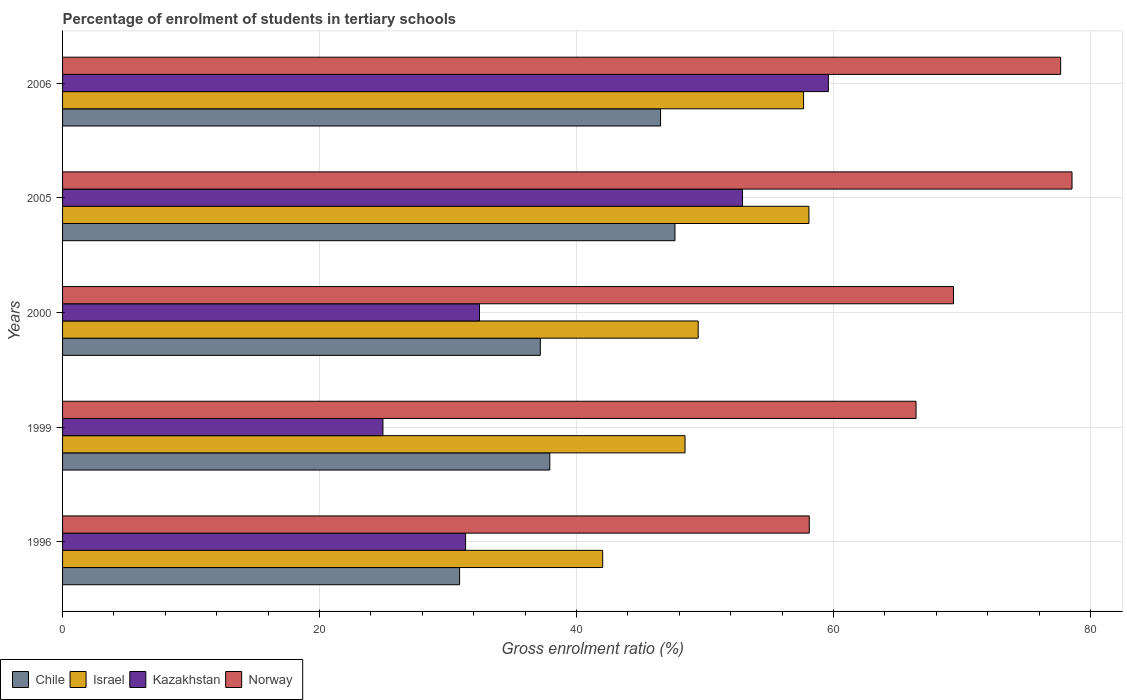How many different coloured bars are there?
Ensure brevity in your answer.  4. Are the number of bars on each tick of the Y-axis equal?
Ensure brevity in your answer.  Yes. How many bars are there on the 2nd tick from the top?
Provide a succinct answer. 4. What is the percentage of students enrolled in tertiary schools in Kazakhstan in 1999?
Your answer should be compact. 24.93. Across all years, what is the maximum percentage of students enrolled in tertiary schools in Israel?
Ensure brevity in your answer.  58.09. Across all years, what is the minimum percentage of students enrolled in tertiary schools in Chile?
Your answer should be very brief. 30.9. What is the total percentage of students enrolled in tertiary schools in Israel in the graph?
Your answer should be compact. 255.72. What is the difference between the percentage of students enrolled in tertiary schools in Kazakhstan in 1999 and that in 2006?
Ensure brevity in your answer.  -34.67. What is the difference between the percentage of students enrolled in tertiary schools in Norway in 1996 and the percentage of students enrolled in tertiary schools in Chile in 2000?
Give a very brief answer. 20.93. What is the average percentage of students enrolled in tertiary schools in Israel per year?
Ensure brevity in your answer.  51.14. In the year 2006, what is the difference between the percentage of students enrolled in tertiary schools in Kazakhstan and percentage of students enrolled in tertiary schools in Chile?
Keep it short and to the point. 13.06. In how many years, is the percentage of students enrolled in tertiary schools in Kazakhstan greater than 40 %?
Provide a succinct answer. 2. What is the ratio of the percentage of students enrolled in tertiary schools in Kazakhstan in 1999 to that in 2006?
Your answer should be compact. 0.42. What is the difference between the highest and the second highest percentage of students enrolled in tertiary schools in Kazakhstan?
Make the answer very short. 6.68. What is the difference between the highest and the lowest percentage of students enrolled in tertiary schools in Chile?
Ensure brevity in your answer.  16.76. Is the sum of the percentage of students enrolled in tertiary schools in Israel in 2000 and 2005 greater than the maximum percentage of students enrolled in tertiary schools in Chile across all years?
Provide a short and direct response. Yes. What does the 3rd bar from the top in 2000 represents?
Keep it short and to the point. Israel. Is it the case that in every year, the sum of the percentage of students enrolled in tertiary schools in Israel and percentage of students enrolled in tertiary schools in Chile is greater than the percentage of students enrolled in tertiary schools in Norway?
Provide a short and direct response. Yes. How many bars are there?
Your answer should be compact. 20. Are all the bars in the graph horizontal?
Offer a very short reply. Yes. Where does the legend appear in the graph?
Offer a terse response. Bottom left. How are the legend labels stacked?
Offer a very short reply. Horizontal. What is the title of the graph?
Offer a very short reply. Percentage of enrolment of students in tertiary schools. Does "Indonesia" appear as one of the legend labels in the graph?
Offer a terse response. No. What is the Gross enrolment ratio (%) in Chile in 1996?
Keep it short and to the point. 30.9. What is the Gross enrolment ratio (%) in Israel in 1996?
Your answer should be compact. 42.04. What is the Gross enrolment ratio (%) in Kazakhstan in 1996?
Ensure brevity in your answer.  31.37. What is the Gross enrolment ratio (%) of Norway in 1996?
Make the answer very short. 58.12. What is the Gross enrolment ratio (%) of Chile in 1999?
Your response must be concise. 37.92. What is the Gross enrolment ratio (%) of Israel in 1999?
Provide a short and direct response. 48.45. What is the Gross enrolment ratio (%) of Kazakhstan in 1999?
Your answer should be very brief. 24.93. What is the Gross enrolment ratio (%) of Norway in 1999?
Your response must be concise. 66.43. What is the Gross enrolment ratio (%) in Chile in 2000?
Give a very brief answer. 37.19. What is the Gross enrolment ratio (%) in Israel in 2000?
Your answer should be very brief. 49.47. What is the Gross enrolment ratio (%) of Kazakhstan in 2000?
Make the answer very short. 32.45. What is the Gross enrolment ratio (%) of Norway in 2000?
Your answer should be very brief. 69.34. What is the Gross enrolment ratio (%) of Chile in 2005?
Provide a succinct answer. 47.66. What is the Gross enrolment ratio (%) in Israel in 2005?
Your answer should be compact. 58.09. What is the Gross enrolment ratio (%) in Kazakhstan in 2005?
Offer a very short reply. 52.92. What is the Gross enrolment ratio (%) of Norway in 2005?
Offer a terse response. 78.57. What is the Gross enrolment ratio (%) in Chile in 2006?
Your answer should be compact. 46.54. What is the Gross enrolment ratio (%) of Israel in 2006?
Give a very brief answer. 57.67. What is the Gross enrolment ratio (%) of Kazakhstan in 2006?
Provide a short and direct response. 59.6. What is the Gross enrolment ratio (%) of Norway in 2006?
Provide a short and direct response. 77.68. Across all years, what is the maximum Gross enrolment ratio (%) in Chile?
Keep it short and to the point. 47.66. Across all years, what is the maximum Gross enrolment ratio (%) of Israel?
Offer a very short reply. 58.09. Across all years, what is the maximum Gross enrolment ratio (%) in Kazakhstan?
Your response must be concise. 59.6. Across all years, what is the maximum Gross enrolment ratio (%) in Norway?
Make the answer very short. 78.57. Across all years, what is the minimum Gross enrolment ratio (%) in Chile?
Give a very brief answer. 30.9. Across all years, what is the minimum Gross enrolment ratio (%) of Israel?
Provide a short and direct response. 42.04. Across all years, what is the minimum Gross enrolment ratio (%) of Kazakhstan?
Offer a terse response. 24.93. Across all years, what is the minimum Gross enrolment ratio (%) of Norway?
Offer a very short reply. 58.12. What is the total Gross enrolment ratio (%) in Chile in the graph?
Make the answer very short. 200.22. What is the total Gross enrolment ratio (%) of Israel in the graph?
Make the answer very short. 255.72. What is the total Gross enrolment ratio (%) in Kazakhstan in the graph?
Keep it short and to the point. 201.28. What is the total Gross enrolment ratio (%) of Norway in the graph?
Provide a short and direct response. 350.14. What is the difference between the Gross enrolment ratio (%) of Chile in 1996 and that in 1999?
Your answer should be very brief. -7.02. What is the difference between the Gross enrolment ratio (%) of Israel in 1996 and that in 1999?
Ensure brevity in your answer.  -6.41. What is the difference between the Gross enrolment ratio (%) of Kazakhstan in 1996 and that in 1999?
Your response must be concise. 6.43. What is the difference between the Gross enrolment ratio (%) in Norway in 1996 and that in 1999?
Ensure brevity in your answer.  -8.31. What is the difference between the Gross enrolment ratio (%) in Chile in 1996 and that in 2000?
Your answer should be compact. -6.28. What is the difference between the Gross enrolment ratio (%) of Israel in 1996 and that in 2000?
Make the answer very short. -7.43. What is the difference between the Gross enrolment ratio (%) of Kazakhstan in 1996 and that in 2000?
Your answer should be very brief. -1.08. What is the difference between the Gross enrolment ratio (%) of Norway in 1996 and that in 2000?
Provide a short and direct response. -11.23. What is the difference between the Gross enrolment ratio (%) of Chile in 1996 and that in 2005?
Provide a succinct answer. -16.76. What is the difference between the Gross enrolment ratio (%) of Israel in 1996 and that in 2005?
Your answer should be very brief. -16.05. What is the difference between the Gross enrolment ratio (%) of Kazakhstan in 1996 and that in 2005?
Offer a very short reply. -21.55. What is the difference between the Gross enrolment ratio (%) in Norway in 1996 and that in 2005?
Ensure brevity in your answer.  -20.45. What is the difference between the Gross enrolment ratio (%) in Chile in 1996 and that in 2006?
Provide a succinct answer. -15.64. What is the difference between the Gross enrolment ratio (%) in Israel in 1996 and that in 2006?
Your answer should be very brief. -15.64. What is the difference between the Gross enrolment ratio (%) of Kazakhstan in 1996 and that in 2006?
Provide a succinct answer. -28.24. What is the difference between the Gross enrolment ratio (%) of Norway in 1996 and that in 2006?
Your answer should be compact. -19.57. What is the difference between the Gross enrolment ratio (%) in Chile in 1999 and that in 2000?
Give a very brief answer. 0.74. What is the difference between the Gross enrolment ratio (%) of Israel in 1999 and that in 2000?
Keep it short and to the point. -1.02. What is the difference between the Gross enrolment ratio (%) in Kazakhstan in 1999 and that in 2000?
Keep it short and to the point. -7.51. What is the difference between the Gross enrolment ratio (%) of Norway in 1999 and that in 2000?
Keep it short and to the point. -2.91. What is the difference between the Gross enrolment ratio (%) of Chile in 1999 and that in 2005?
Keep it short and to the point. -9.74. What is the difference between the Gross enrolment ratio (%) in Israel in 1999 and that in 2005?
Provide a succinct answer. -9.64. What is the difference between the Gross enrolment ratio (%) of Kazakhstan in 1999 and that in 2005?
Your response must be concise. -27.99. What is the difference between the Gross enrolment ratio (%) of Norway in 1999 and that in 2005?
Ensure brevity in your answer.  -12.14. What is the difference between the Gross enrolment ratio (%) in Chile in 1999 and that in 2006?
Make the answer very short. -8.62. What is the difference between the Gross enrolment ratio (%) of Israel in 1999 and that in 2006?
Make the answer very short. -9.23. What is the difference between the Gross enrolment ratio (%) of Kazakhstan in 1999 and that in 2006?
Provide a short and direct response. -34.67. What is the difference between the Gross enrolment ratio (%) of Norway in 1999 and that in 2006?
Ensure brevity in your answer.  -11.26. What is the difference between the Gross enrolment ratio (%) in Chile in 2000 and that in 2005?
Your response must be concise. -10.48. What is the difference between the Gross enrolment ratio (%) of Israel in 2000 and that in 2005?
Make the answer very short. -8.62. What is the difference between the Gross enrolment ratio (%) in Kazakhstan in 2000 and that in 2005?
Offer a very short reply. -20.48. What is the difference between the Gross enrolment ratio (%) of Norway in 2000 and that in 2005?
Offer a terse response. -9.23. What is the difference between the Gross enrolment ratio (%) in Chile in 2000 and that in 2006?
Keep it short and to the point. -9.36. What is the difference between the Gross enrolment ratio (%) of Israel in 2000 and that in 2006?
Provide a succinct answer. -8.2. What is the difference between the Gross enrolment ratio (%) in Kazakhstan in 2000 and that in 2006?
Keep it short and to the point. -27.16. What is the difference between the Gross enrolment ratio (%) of Norway in 2000 and that in 2006?
Keep it short and to the point. -8.34. What is the difference between the Gross enrolment ratio (%) of Chile in 2005 and that in 2006?
Your answer should be compact. 1.12. What is the difference between the Gross enrolment ratio (%) in Israel in 2005 and that in 2006?
Ensure brevity in your answer.  0.42. What is the difference between the Gross enrolment ratio (%) in Kazakhstan in 2005 and that in 2006?
Provide a short and direct response. -6.68. What is the difference between the Gross enrolment ratio (%) in Norway in 2005 and that in 2006?
Provide a short and direct response. 0.88. What is the difference between the Gross enrolment ratio (%) of Chile in 1996 and the Gross enrolment ratio (%) of Israel in 1999?
Your answer should be very brief. -17.55. What is the difference between the Gross enrolment ratio (%) in Chile in 1996 and the Gross enrolment ratio (%) in Kazakhstan in 1999?
Your answer should be very brief. 5.97. What is the difference between the Gross enrolment ratio (%) of Chile in 1996 and the Gross enrolment ratio (%) of Norway in 1999?
Your answer should be very brief. -35.53. What is the difference between the Gross enrolment ratio (%) in Israel in 1996 and the Gross enrolment ratio (%) in Kazakhstan in 1999?
Provide a short and direct response. 17.1. What is the difference between the Gross enrolment ratio (%) in Israel in 1996 and the Gross enrolment ratio (%) in Norway in 1999?
Keep it short and to the point. -24.39. What is the difference between the Gross enrolment ratio (%) of Kazakhstan in 1996 and the Gross enrolment ratio (%) of Norway in 1999?
Your answer should be very brief. -35.06. What is the difference between the Gross enrolment ratio (%) of Chile in 1996 and the Gross enrolment ratio (%) of Israel in 2000?
Offer a very short reply. -18.57. What is the difference between the Gross enrolment ratio (%) in Chile in 1996 and the Gross enrolment ratio (%) in Kazakhstan in 2000?
Ensure brevity in your answer.  -1.55. What is the difference between the Gross enrolment ratio (%) in Chile in 1996 and the Gross enrolment ratio (%) in Norway in 2000?
Your answer should be compact. -38.44. What is the difference between the Gross enrolment ratio (%) of Israel in 1996 and the Gross enrolment ratio (%) of Kazakhstan in 2000?
Give a very brief answer. 9.59. What is the difference between the Gross enrolment ratio (%) in Israel in 1996 and the Gross enrolment ratio (%) in Norway in 2000?
Make the answer very short. -27.3. What is the difference between the Gross enrolment ratio (%) of Kazakhstan in 1996 and the Gross enrolment ratio (%) of Norway in 2000?
Provide a short and direct response. -37.97. What is the difference between the Gross enrolment ratio (%) in Chile in 1996 and the Gross enrolment ratio (%) in Israel in 2005?
Offer a terse response. -27.19. What is the difference between the Gross enrolment ratio (%) in Chile in 1996 and the Gross enrolment ratio (%) in Kazakhstan in 2005?
Your answer should be compact. -22.02. What is the difference between the Gross enrolment ratio (%) of Chile in 1996 and the Gross enrolment ratio (%) of Norway in 2005?
Your response must be concise. -47.67. What is the difference between the Gross enrolment ratio (%) in Israel in 1996 and the Gross enrolment ratio (%) in Kazakhstan in 2005?
Ensure brevity in your answer.  -10.88. What is the difference between the Gross enrolment ratio (%) of Israel in 1996 and the Gross enrolment ratio (%) of Norway in 2005?
Keep it short and to the point. -36.53. What is the difference between the Gross enrolment ratio (%) of Kazakhstan in 1996 and the Gross enrolment ratio (%) of Norway in 2005?
Your answer should be compact. -47.2. What is the difference between the Gross enrolment ratio (%) of Chile in 1996 and the Gross enrolment ratio (%) of Israel in 2006?
Provide a succinct answer. -26.77. What is the difference between the Gross enrolment ratio (%) in Chile in 1996 and the Gross enrolment ratio (%) in Kazakhstan in 2006?
Provide a short and direct response. -28.7. What is the difference between the Gross enrolment ratio (%) in Chile in 1996 and the Gross enrolment ratio (%) in Norway in 2006?
Offer a very short reply. -46.78. What is the difference between the Gross enrolment ratio (%) in Israel in 1996 and the Gross enrolment ratio (%) in Kazakhstan in 2006?
Make the answer very short. -17.57. What is the difference between the Gross enrolment ratio (%) of Israel in 1996 and the Gross enrolment ratio (%) of Norway in 2006?
Offer a very short reply. -35.65. What is the difference between the Gross enrolment ratio (%) of Kazakhstan in 1996 and the Gross enrolment ratio (%) of Norway in 2006?
Keep it short and to the point. -46.31. What is the difference between the Gross enrolment ratio (%) in Chile in 1999 and the Gross enrolment ratio (%) in Israel in 2000?
Ensure brevity in your answer.  -11.55. What is the difference between the Gross enrolment ratio (%) of Chile in 1999 and the Gross enrolment ratio (%) of Kazakhstan in 2000?
Provide a succinct answer. 5.47. What is the difference between the Gross enrolment ratio (%) in Chile in 1999 and the Gross enrolment ratio (%) in Norway in 2000?
Give a very brief answer. -31.42. What is the difference between the Gross enrolment ratio (%) in Israel in 1999 and the Gross enrolment ratio (%) in Kazakhstan in 2000?
Provide a short and direct response. 16. What is the difference between the Gross enrolment ratio (%) of Israel in 1999 and the Gross enrolment ratio (%) of Norway in 2000?
Your answer should be compact. -20.89. What is the difference between the Gross enrolment ratio (%) of Kazakhstan in 1999 and the Gross enrolment ratio (%) of Norway in 2000?
Provide a succinct answer. -44.41. What is the difference between the Gross enrolment ratio (%) in Chile in 1999 and the Gross enrolment ratio (%) in Israel in 2005?
Ensure brevity in your answer.  -20.17. What is the difference between the Gross enrolment ratio (%) of Chile in 1999 and the Gross enrolment ratio (%) of Kazakhstan in 2005?
Offer a very short reply. -15. What is the difference between the Gross enrolment ratio (%) in Chile in 1999 and the Gross enrolment ratio (%) in Norway in 2005?
Your answer should be very brief. -40.65. What is the difference between the Gross enrolment ratio (%) of Israel in 1999 and the Gross enrolment ratio (%) of Kazakhstan in 2005?
Your answer should be compact. -4.47. What is the difference between the Gross enrolment ratio (%) in Israel in 1999 and the Gross enrolment ratio (%) in Norway in 2005?
Provide a succinct answer. -30.12. What is the difference between the Gross enrolment ratio (%) of Kazakhstan in 1999 and the Gross enrolment ratio (%) of Norway in 2005?
Provide a succinct answer. -53.63. What is the difference between the Gross enrolment ratio (%) in Chile in 1999 and the Gross enrolment ratio (%) in Israel in 2006?
Make the answer very short. -19.75. What is the difference between the Gross enrolment ratio (%) of Chile in 1999 and the Gross enrolment ratio (%) of Kazakhstan in 2006?
Your answer should be very brief. -21.68. What is the difference between the Gross enrolment ratio (%) in Chile in 1999 and the Gross enrolment ratio (%) in Norway in 2006?
Ensure brevity in your answer.  -39.76. What is the difference between the Gross enrolment ratio (%) in Israel in 1999 and the Gross enrolment ratio (%) in Kazakhstan in 2006?
Ensure brevity in your answer.  -11.16. What is the difference between the Gross enrolment ratio (%) in Israel in 1999 and the Gross enrolment ratio (%) in Norway in 2006?
Keep it short and to the point. -29.24. What is the difference between the Gross enrolment ratio (%) of Kazakhstan in 1999 and the Gross enrolment ratio (%) of Norway in 2006?
Provide a short and direct response. -52.75. What is the difference between the Gross enrolment ratio (%) in Chile in 2000 and the Gross enrolment ratio (%) in Israel in 2005?
Your response must be concise. -20.91. What is the difference between the Gross enrolment ratio (%) of Chile in 2000 and the Gross enrolment ratio (%) of Kazakhstan in 2005?
Offer a terse response. -15.74. What is the difference between the Gross enrolment ratio (%) in Chile in 2000 and the Gross enrolment ratio (%) in Norway in 2005?
Provide a succinct answer. -41.38. What is the difference between the Gross enrolment ratio (%) in Israel in 2000 and the Gross enrolment ratio (%) in Kazakhstan in 2005?
Your response must be concise. -3.45. What is the difference between the Gross enrolment ratio (%) of Israel in 2000 and the Gross enrolment ratio (%) of Norway in 2005?
Offer a very short reply. -29.1. What is the difference between the Gross enrolment ratio (%) in Kazakhstan in 2000 and the Gross enrolment ratio (%) in Norway in 2005?
Provide a succinct answer. -46.12. What is the difference between the Gross enrolment ratio (%) in Chile in 2000 and the Gross enrolment ratio (%) in Israel in 2006?
Provide a succinct answer. -20.49. What is the difference between the Gross enrolment ratio (%) in Chile in 2000 and the Gross enrolment ratio (%) in Kazakhstan in 2006?
Provide a short and direct response. -22.42. What is the difference between the Gross enrolment ratio (%) in Chile in 2000 and the Gross enrolment ratio (%) in Norway in 2006?
Your answer should be compact. -40.5. What is the difference between the Gross enrolment ratio (%) of Israel in 2000 and the Gross enrolment ratio (%) of Kazakhstan in 2006?
Make the answer very short. -10.13. What is the difference between the Gross enrolment ratio (%) in Israel in 2000 and the Gross enrolment ratio (%) in Norway in 2006?
Provide a succinct answer. -28.21. What is the difference between the Gross enrolment ratio (%) in Kazakhstan in 2000 and the Gross enrolment ratio (%) in Norway in 2006?
Give a very brief answer. -45.24. What is the difference between the Gross enrolment ratio (%) in Chile in 2005 and the Gross enrolment ratio (%) in Israel in 2006?
Make the answer very short. -10.01. What is the difference between the Gross enrolment ratio (%) in Chile in 2005 and the Gross enrolment ratio (%) in Kazakhstan in 2006?
Offer a very short reply. -11.94. What is the difference between the Gross enrolment ratio (%) in Chile in 2005 and the Gross enrolment ratio (%) in Norway in 2006?
Make the answer very short. -30.02. What is the difference between the Gross enrolment ratio (%) in Israel in 2005 and the Gross enrolment ratio (%) in Kazakhstan in 2006?
Provide a succinct answer. -1.51. What is the difference between the Gross enrolment ratio (%) in Israel in 2005 and the Gross enrolment ratio (%) in Norway in 2006?
Your response must be concise. -19.59. What is the difference between the Gross enrolment ratio (%) in Kazakhstan in 2005 and the Gross enrolment ratio (%) in Norway in 2006?
Provide a short and direct response. -24.76. What is the average Gross enrolment ratio (%) in Chile per year?
Ensure brevity in your answer.  40.04. What is the average Gross enrolment ratio (%) of Israel per year?
Provide a short and direct response. 51.14. What is the average Gross enrolment ratio (%) of Kazakhstan per year?
Keep it short and to the point. 40.26. What is the average Gross enrolment ratio (%) of Norway per year?
Ensure brevity in your answer.  70.03. In the year 1996, what is the difference between the Gross enrolment ratio (%) in Chile and Gross enrolment ratio (%) in Israel?
Provide a succinct answer. -11.14. In the year 1996, what is the difference between the Gross enrolment ratio (%) of Chile and Gross enrolment ratio (%) of Kazakhstan?
Your answer should be compact. -0.47. In the year 1996, what is the difference between the Gross enrolment ratio (%) in Chile and Gross enrolment ratio (%) in Norway?
Your answer should be very brief. -27.22. In the year 1996, what is the difference between the Gross enrolment ratio (%) in Israel and Gross enrolment ratio (%) in Kazakhstan?
Offer a terse response. 10.67. In the year 1996, what is the difference between the Gross enrolment ratio (%) in Israel and Gross enrolment ratio (%) in Norway?
Your answer should be compact. -16.08. In the year 1996, what is the difference between the Gross enrolment ratio (%) in Kazakhstan and Gross enrolment ratio (%) in Norway?
Provide a short and direct response. -26.75. In the year 1999, what is the difference between the Gross enrolment ratio (%) of Chile and Gross enrolment ratio (%) of Israel?
Your answer should be very brief. -10.53. In the year 1999, what is the difference between the Gross enrolment ratio (%) in Chile and Gross enrolment ratio (%) in Kazakhstan?
Offer a terse response. 12.99. In the year 1999, what is the difference between the Gross enrolment ratio (%) of Chile and Gross enrolment ratio (%) of Norway?
Make the answer very short. -28.51. In the year 1999, what is the difference between the Gross enrolment ratio (%) of Israel and Gross enrolment ratio (%) of Kazakhstan?
Provide a short and direct response. 23.51. In the year 1999, what is the difference between the Gross enrolment ratio (%) of Israel and Gross enrolment ratio (%) of Norway?
Your answer should be very brief. -17.98. In the year 1999, what is the difference between the Gross enrolment ratio (%) in Kazakhstan and Gross enrolment ratio (%) in Norway?
Provide a succinct answer. -41.49. In the year 2000, what is the difference between the Gross enrolment ratio (%) of Chile and Gross enrolment ratio (%) of Israel?
Your answer should be compact. -12.29. In the year 2000, what is the difference between the Gross enrolment ratio (%) in Chile and Gross enrolment ratio (%) in Kazakhstan?
Your response must be concise. 4.74. In the year 2000, what is the difference between the Gross enrolment ratio (%) of Chile and Gross enrolment ratio (%) of Norway?
Your answer should be compact. -32.16. In the year 2000, what is the difference between the Gross enrolment ratio (%) of Israel and Gross enrolment ratio (%) of Kazakhstan?
Offer a terse response. 17.02. In the year 2000, what is the difference between the Gross enrolment ratio (%) of Israel and Gross enrolment ratio (%) of Norway?
Ensure brevity in your answer.  -19.87. In the year 2000, what is the difference between the Gross enrolment ratio (%) of Kazakhstan and Gross enrolment ratio (%) of Norway?
Provide a short and direct response. -36.9. In the year 2005, what is the difference between the Gross enrolment ratio (%) of Chile and Gross enrolment ratio (%) of Israel?
Offer a terse response. -10.43. In the year 2005, what is the difference between the Gross enrolment ratio (%) in Chile and Gross enrolment ratio (%) in Kazakhstan?
Offer a very short reply. -5.26. In the year 2005, what is the difference between the Gross enrolment ratio (%) of Chile and Gross enrolment ratio (%) of Norway?
Your answer should be compact. -30.9. In the year 2005, what is the difference between the Gross enrolment ratio (%) of Israel and Gross enrolment ratio (%) of Kazakhstan?
Ensure brevity in your answer.  5.17. In the year 2005, what is the difference between the Gross enrolment ratio (%) of Israel and Gross enrolment ratio (%) of Norway?
Provide a succinct answer. -20.48. In the year 2005, what is the difference between the Gross enrolment ratio (%) of Kazakhstan and Gross enrolment ratio (%) of Norway?
Your response must be concise. -25.65. In the year 2006, what is the difference between the Gross enrolment ratio (%) in Chile and Gross enrolment ratio (%) in Israel?
Provide a succinct answer. -11.13. In the year 2006, what is the difference between the Gross enrolment ratio (%) of Chile and Gross enrolment ratio (%) of Kazakhstan?
Offer a very short reply. -13.06. In the year 2006, what is the difference between the Gross enrolment ratio (%) in Chile and Gross enrolment ratio (%) in Norway?
Keep it short and to the point. -31.14. In the year 2006, what is the difference between the Gross enrolment ratio (%) in Israel and Gross enrolment ratio (%) in Kazakhstan?
Provide a short and direct response. -1.93. In the year 2006, what is the difference between the Gross enrolment ratio (%) of Israel and Gross enrolment ratio (%) of Norway?
Your answer should be compact. -20.01. In the year 2006, what is the difference between the Gross enrolment ratio (%) in Kazakhstan and Gross enrolment ratio (%) in Norway?
Ensure brevity in your answer.  -18.08. What is the ratio of the Gross enrolment ratio (%) of Chile in 1996 to that in 1999?
Give a very brief answer. 0.81. What is the ratio of the Gross enrolment ratio (%) in Israel in 1996 to that in 1999?
Your response must be concise. 0.87. What is the ratio of the Gross enrolment ratio (%) of Kazakhstan in 1996 to that in 1999?
Your response must be concise. 1.26. What is the ratio of the Gross enrolment ratio (%) in Norway in 1996 to that in 1999?
Your answer should be very brief. 0.87. What is the ratio of the Gross enrolment ratio (%) of Chile in 1996 to that in 2000?
Give a very brief answer. 0.83. What is the ratio of the Gross enrolment ratio (%) in Israel in 1996 to that in 2000?
Keep it short and to the point. 0.85. What is the ratio of the Gross enrolment ratio (%) in Kazakhstan in 1996 to that in 2000?
Give a very brief answer. 0.97. What is the ratio of the Gross enrolment ratio (%) in Norway in 1996 to that in 2000?
Your answer should be very brief. 0.84. What is the ratio of the Gross enrolment ratio (%) in Chile in 1996 to that in 2005?
Keep it short and to the point. 0.65. What is the ratio of the Gross enrolment ratio (%) in Israel in 1996 to that in 2005?
Keep it short and to the point. 0.72. What is the ratio of the Gross enrolment ratio (%) of Kazakhstan in 1996 to that in 2005?
Provide a succinct answer. 0.59. What is the ratio of the Gross enrolment ratio (%) in Norway in 1996 to that in 2005?
Make the answer very short. 0.74. What is the ratio of the Gross enrolment ratio (%) of Chile in 1996 to that in 2006?
Offer a terse response. 0.66. What is the ratio of the Gross enrolment ratio (%) of Israel in 1996 to that in 2006?
Give a very brief answer. 0.73. What is the ratio of the Gross enrolment ratio (%) of Kazakhstan in 1996 to that in 2006?
Offer a very short reply. 0.53. What is the ratio of the Gross enrolment ratio (%) in Norway in 1996 to that in 2006?
Provide a short and direct response. 0.75. What is the ratio of the Gross enrolment ratio (%) of Chile in 1999 to that in 2000?
Offer a terse response. 1.02. What is the ratio of the Gross enrolment ratio (%) in Israel in 1999 to that in 2000?
Make the answer very short. 0.98. What is the ratio of the Gross enrolment ratio (%) of Kazakhstan in 1999 to that in 2000?
Your answer should be compact. 0.77. What is the ratio of the Gross enrolment ratio (%) in Norway in 1999 to that in 2000?
Offer a terse response. 0.96. What is the ratio of the Gross enrolment ratio (%) in Chile in 1999 to that in 2005?
Provide a short and direct response. 0.8. What is the ratio of the Gross enrolment ratio (%) of Israel in 1999 to that in 2005?
Offer a terse response. 0.83. What is the ratio of the Gross enrolment ratio (%) in Kazakhstan in 1999 to that in 2005?
Give a very brief answer. 0.47. What is the ratio of the Gross enrolment ratio (%) in Norway in 1999 to that in 2005?
Give a very brief answer. 0.85. What is the ratio of the Gross enrolment ratio (%) in Chile in 1999 to that in 2006?
Your response must be concise. 0.81. What is the ratio of the Gross enrolment ratio (%) in Israel in 1999 to that in 2006?
Provide a short and direct response. 0.84. What is the ratio of the Gross enrolment ratio (%) in Kazakhstan in 1999 to that in 2006?
Provide a short and direct response. 0.42. What is the ratio of the Gross enrolment ratio (%) in Norway in 1999 to that in 2006?
Give a very brief answer. 0.86. What is the ratio of the Gross enrolment ratio (%) of Chile in 2000 to that in 2005?
Your answer should be very brief. 0.78. What is the ratio of the Gross enrolment ratio (%) in Israel in 2000 to that in 2005?
Ensure brevity in your answer.  0.85. What is the ratio of the Gross enrolment ratio (%) of Kazakhstan in 2000 to that in 2005?
Offer a terse response. 0.61. What is the ratio of the Gross enrolment ratio (%) in Norway in 2000 to that in 2005?
Offer a terse response. 0.88. What is the ratio of the Gross enrolment ratio (%) of Chile in 2000 to that in 2006?
Ensure brevity in your answer.  0.8. What is the ratio of the Gross enrolment ratio (%) in Israel in 2000 to that in 2006?
Your answer should be compact. 0.86. What is the ratio of the Gross enrolment ratio (%) of Kazakhstan in 2000 to that in 2006?
Provide a short and direct response. 0.54. What is the ratio of the Gross enrolment ratio (%) of Norway in 2000 to that in 2006?
Your answer should be very brief. 0.89. What is the ratio of the Gross enrolment ratio (%) of Chile in 2005 to that in 2006?
Make the answer very short. 1.02. What is the ratio of the Gross enrolment ratio (%) in Israel in 2005 to that in 2006?
Your answer should be very brief. 1.01. What is the ratio of the Gross enrolment ratio (%) in Kazakhstan in 2005 to that in 2006?
Your answer should be very brief. 0.89. What is the ratio of the Gross enrolment ratio (%) of Norway in 2005 to that in 2006?
Ensure brevity in your answer.  1.01. What is the difference between the highest and the second highest Gross enrolment ratio (%) of Chile?
Give a very brief answer. 1.12. What is the difference between the highest and the second highest Gross enrolment ratio (%) in Israel?
Give a very brief answer. 0.42. What is the difference between the highest and the second highest Gross enrolment ratio (%) in Kazakhstan?
Keep it short and to the point. 6.68. What is the difference between the highest and the second highest Gross enrolment ratio (%) in Norway?
Your answer should be very brief. 0.88. What is the difference between the highest and the lowest Gross enrolment ratio (%) in Chile?
Your answer should be very brief. 16.76. What is the difference between the highest and the lowest Gross enrolment ratio (%) in Israel?
Give a very brief answer. 16.05. What is the difference between the highest and the lowest Gross enrolment ratio (%) of Kazakhstan?
Provide a succinct answer. 34.67. What is the difference between the highest and the lowest Gross enrolment ratio (%) in Norway?
Give a very brief answer. 20.45. 